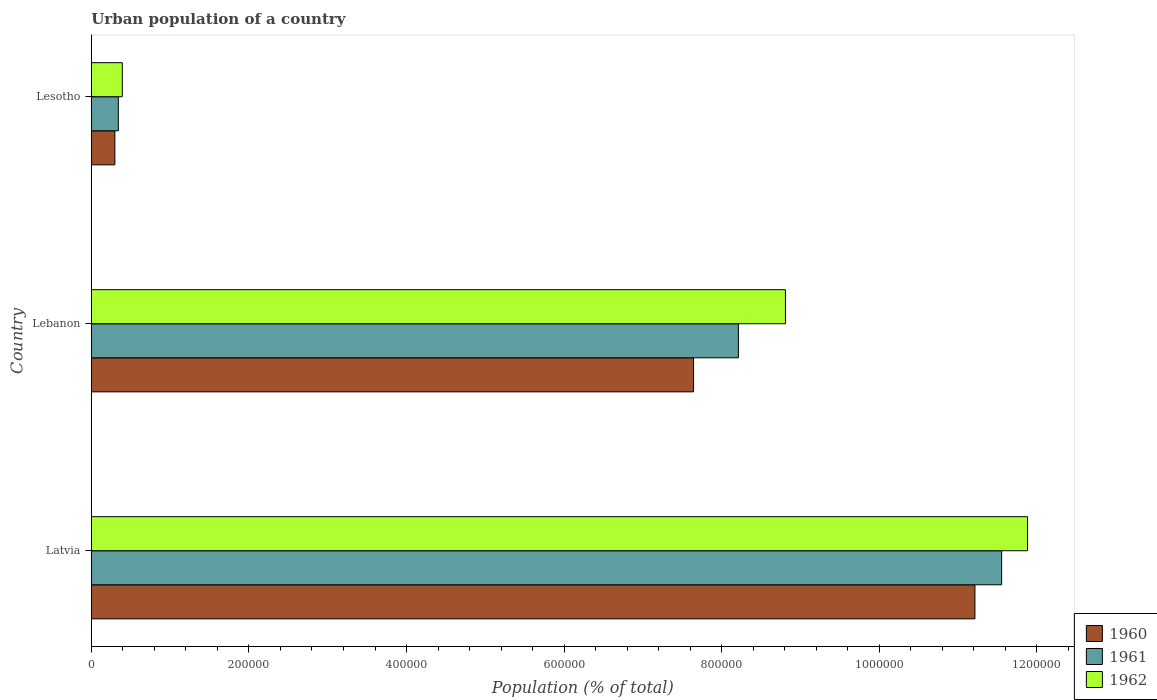How many groups of bars are there?
Your response must be concise. 3. Are the number of bars per tick equal to the number of legend labels?
Ensure brevity in your answer.  Yes. Are the number of bars on each tick of the Y-axis equal?
Offer a very short reply. Yes. How many bars are there on the 2nd tick from the top?
Keep it short and to the point. 3. What is the label of the 3rd group of bars from the top?
Give a very brief answer. Latvia. In how many cases, is the number of bars for a given country not equal to the number of legend labels?
Your answer should be very brief. 0. What is the urban population in 1962 in Lesotho?
Offer a terse response. 3.94e+04. Across all countries, what is the maximum urban population in 1960?
Provide a short and direct response. 1.12e+06. Across all countries, what is the minimum urban population in 1961?
Offer a terse response. 3.43e+04. In which country was the urban population in 1960 maximum?
Keep it short and to the point. Latvia. In which country was the urban population in 1962 minimum?
Keep it short and to the point. Lesotho. What is the total urban population in 1960 in the graph?
Your answer should be very brief. 1.92e+06. What is the difference between the urban population in 1960 in Latvia and that in Lesotho?
Provide a short and direct response. 1.09e+06. What is the difference between the urban population in 1960 in Lebanon and the urban population in 1962 in Latvia?
Your answer should be very brief. -4.24e+05. What is the average urban population in 1961 per country?
Provide a short and direct response. 6.70e+05. What is the difference between the urban population in 1962 and urban population in 1961 in Lesotho?
Ensure brevity in your answer.  5064. What is the ratio of the urban population in 1960 in Lebanon to that in Lesotho?
Offer a terse response. 25.56. Is the urban population in 1961 in Lebanon less than that in Lesotho?
Provide a succinct answer. No. Is the difference between the urban population in 1962 in Latvia and Lesotho greater than the difference between the urban population in 1961 in Latvia and Lesotho?
Offer a very short reply. Yes. What is the difference between the highest and the second highest urban population in 1961?
Make the answer very short. 3.34e+05. What is the difference between the highest and the lowest urban population in 1961?
Make the answer very short. 1.12e+06. Are all the bars in the graph horizontal?
Your answer should be very brief. Yes. What is the difference between two consecutive major ticks on the X-axis?
Your answer should be very brief. 2.00e+05. Does the graph contain any zero values?
Your answer should be compact. No. Where does the legend appear in the graph?
Make the answer very short. Bottom right. What is the title of the graph?
Your response must be concise. Urban population of a country. What is the label or title of the X-axis?
Keep it short and to the point. Population (% of total). What is the Population (% of total) in 1960 in Latvia?
Offer a terse response. 1.12e+06. What is the Population (% of total) in 1961 in Latvia?
Your response must be concise. 1.16e+06. What is the Population (% of total) in 1962 in Latvia?
Ensure brevity in your answer.  1.19e+06. What is the Population (% of total) of 1960 in Lebanon?
Give a very brief answer. 7.64e+05. What is the Population (% of total) in 1961 in Lebanon?
Offer a very short reply. 8.21e+05. What is the Population (% of total) in 1962 in Lebanon?
Offer a terse response. 8.81e+05. What is the Population (% of total) of 1960 in Lesotho?
Your answer should be compact. 2.99e+04. What is the Population (% of total) of 1961 in Lesotho?
Provide a succinct answer. 3.43e+04. What is the Population (% of total) in 1962 in Lesotho?
Your response must be concise. 3.94e+04. Across all countries, what is the maximum Population (% of total) in 1960?
Make the answer very short. 1.12e+06. Across all countries, what is the maximum Population (% of total) of 1961?
Ensure brevity in your answer.  1.16e+06. Across all countries, what is the maximum Population (% of total) of 1962?
Your answer should be very brief. 1.19e+06. Across all countries, what is the minimum Population (% of total) of 1960?
Your answer should be compact. 2.99e+04. Across all countries, what is the minimum Population (% of total) in 1961?
Ensure brevity in your answer.  3.43e+04. Across all countries, what is the minimum Population (% of total) in 1962?
Keep it short and to the point. 3.94e+04. What is the total Population (% of total) in 1960 in the graph?
Ensure brevity in your answer.  1.92e+06. What is the total Population (% of total) of 1961 in the graph?
Ensure brevity in your answer.  2.01e+06. What is the total Population (% of total) of 1962 in the graph?
Ensure brevity in your answer.  2.11e+06. What is the difference between the Population (% of total) in 1960 in Latvia and that in Lebanon?
Your response must be concise. 3.57e+05. What is the difference between the Population (% of total) in 1961 in Latvia and that in Lebanon?
Your answer should be very brief. 3.34e+05. What is the difference between the Population (% of total) of 1962 in Latvia and that in Lebanon?
Offer a terse response. 3.07e+05. What is the difference between the Population (% of total) in 1960 in Latvia and that in Lesotho?
Your answer should be very brief. 1.09e+06. What is the difference between the Population (% of total) of 1961 in Latvia and that in Lesotho?
Keep it short and to the point. 1.12e+06. What is the difference between the Population (% of total) in 1962 in Latvia and that in Lesotho?
Your response must be concise. 1.15e+06. What is the difference between the Population (% of total) in 1960 in Lebanon and that in Lesotho?
Your answer should be compact. 7.34e+05. What is the difference between the Population (% of total) in 1961 in Lebanon and that in Lesotho?
Offer a terse response. 7.87e+05. What is the difference between the Population (% of total) of 1962 in Lebanon and that in Lesotho?
Make the answer very short. 8.41e+05. What is the difference between the Population (% of total) of 1960 in Latvia and the Population (% of total) of 1961 in Lebanon?
Your answer should be compact. 3.00e+05. What is the difference between the Population (% of total) of 1960 in Latvia and the Population (% of total) of 1962 in Lebanon?
Provide a succinct answer. 2.40e+05. What is the difference between the Population (% of total) in 1961 in Latvia and the Population (% of total) in 1962 in Lebanon?
Your response must be concise. 2.74e+05. What is the difference between the Population (% of total) of 1960 in Latvia and the Population (% of total) of 1961 in Lesotho?
Give a very brief answer. 1.09e+06. What is the difference between the Population (% of total) in 1960 in Latvia and the Population (% of total) in 1962 in Lesotho?
Offer a terse response. 1.08e+06. What is the difference between the Population (% of total) of 1961 in Latvia and the Population (% of total) of 1962 in Lesotho?
Keep it short and to the point. 1.12e+06. What is the difference between the Population (% of total) in 1960 in Lebanon and the Population (% of total) in 1961 in Lesotho?
Offer a terse response. 7.30e+05. What is the difference between the Population (% of total) of 1960 in Lebanon and the Population (% of total) of 1962 in Lesotho?
Provide a succinct answer. 7.25e+05. What is the difference between the Population (% of total) of 1961 in Lebanon and the Population (% of total) of 1962 in Lesotho?
Give a very brief answer. 7.82e+05. What is the average Population (% of total) of 1960 per country?
Your response must be concise. 6.38e+05. What is the average Population (% of total) of 1961 per country?
Provide a short and direct response. 6.70e+05. What is the average Population (% of total) in 1962 per country?
Provide a succinct answer. 7.03e+05. What is the difference between the Population (% of total) in 1960 and Population (% of total) in 1961 in Latvia?
Keep it short and to the point. -3.39e+04. What is the difference between the Population (% of total) in 1960 and Population (% of total) in 1962 in Latvia?
Your answer should be very brief. -6.68e+04. What is the difference between the Population (% of total) of 1961 and Population (% of total) of 1962 in Latvia?
Ensure brevity in your answer.  -3.29e+04. What is the difference between the Population (% of total) of 1960 and Population (% of total) of 1961 in Lebanon?
Your answer should be very brief. -5.69e+04. What is the difference between the Population (% of total) of 1960 and Population (% of total) of 1962 in Lebanon?
Offer a terse response. -1.17e+05. What is the difference between the Population (% of total) in 1961 and Population (% of total) in 1962 in Lebanon?
Make the answer very short. -5.97e+04. What is the difference between the Population (% of total) of 1960 and Population (% of total) of 1961 in Lesotho?
Offer a very short reply. -4402. What is the difference between the Population (% of total) in 1960 and Population (% of total) in 1962 in Lesotho?
Offer a very short reply. -9466. What is the difference between the Population (% of total) in 1961 and Population (% of total) in 1962 in Lesotho?
Provide a succinct answer. -5064. What is the ratio of the Population (% of total) of 1960 in Latvia to that in Lebanon?
Your response must be concise. 1.47. What is the ratio of the Population (% of total) of 1961 in Latvia to that in Lebanon?
Ensure brevity in your answer.  1.41. What is the ratio of the Population (% of total) in 1962 in Latvia to that in Lebanon?
Offer a terse response. 1.35. What is the ratio of the Population (% of total) of 1960 in Latvia to that in Lesotho?
Your response must be concise. 37.5. What is the ratio of the Population (% of total) in 1961 in Latvia to that in Lesotho?
Your answer should be very brief. 33.68. What is the ratio of the Population (% of total) of 1962 in Latvia to that in Lesotho?
Offer a very short reply. 30.18. What is the ratio of the Population (% of total) of 1960 in Lebanon to that in Lesotho?
Keep it short and to the point. 25.56. What is the ratio of the Population (% of total) in 1961 in Lebanon to that in Lesotho?
Provide a short and direct response. 23.94. What is the ratio of the Population (% of total) in 1962 in Lebanon to that in Lesotho?
Your answer should be very brief. 22.37. What is the difference between the highest and the second highest Population (% of total) of 1960?
Make the answer very short. 3.57e+05. What is the difference between the highest and the second highest Population (% of total) in 1961?
Your response must be concise. 3.34e+05. What is the difference between the highest and the second highest Population (% of total) in 1962?
Provide a succinct answer. 3.07e+05. What is the difference between the highest and the lowest Population (% of total) of 1960?
Ensure brevity in your answer.  1.09e+06. What is the difference between the highest and the lowest Population (% of total) in 1961?
Provide a short and direct response. 1.12e+06. What is the difference between the highest and the lowest Population (% of total) in 1962?
Ensure brevity in your answer.  1.15e+06. 